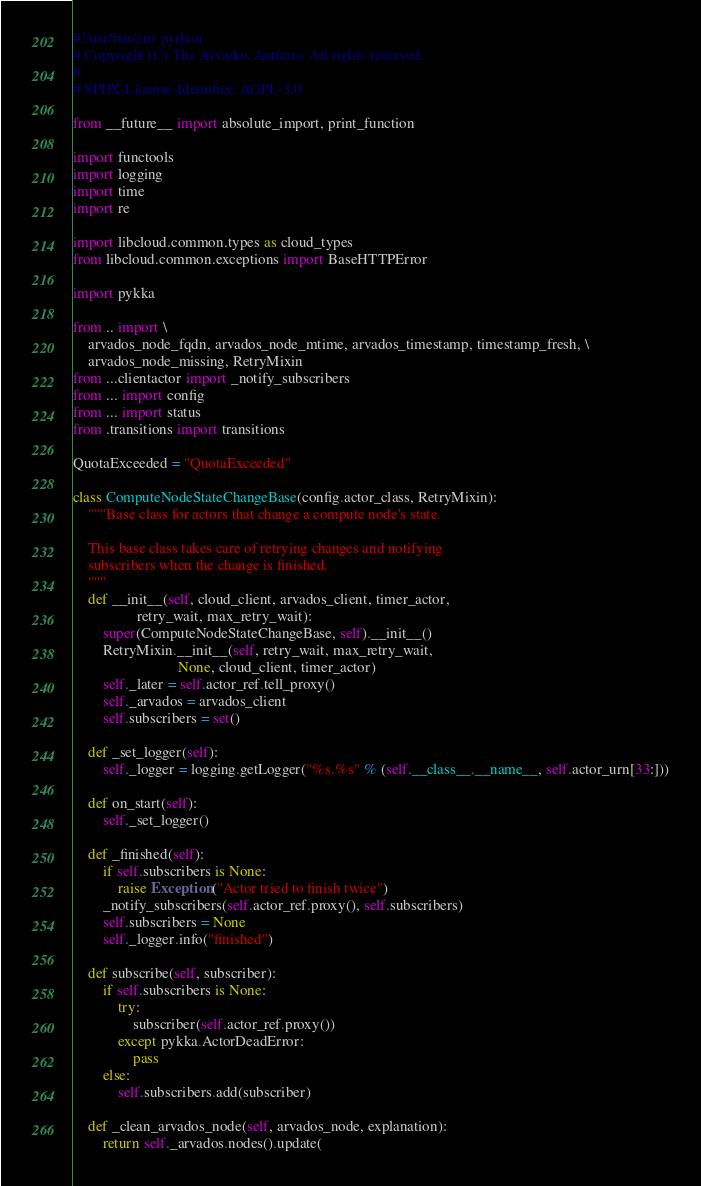<code> <loc_0><loc_0><loc_500><loc_500><_Python_>#!/usr/bin/env python
# Copyright (C) The Arvados Authors. All rights reserved.
#
# SPDX-License-Identifier: AGPL-3.0

from __future__ import absolute_import, print_function

import functools
import logging
import time
import re

import libcloud.common.types as cloud_types
from libcloud.common.exceptions import BaseHTTPError

import pykka

from .. import \
    arvados_node_fqdn, arvados_node_mtime, arvados_timestamp, timestamp_fresh, \
    arvados_node_missing, RetryMixin
from ...clientactor import _notify_subscribers
from ... import config
from ... import status
from .transitions import transitions

QuotaExceeded = "QuotaExceeded"

class ComputeNodeStateChangeBase(config.actor_class, RetryMixin):
    """Base class for actors that change a compute node's state.

    This base class takes care of retrying changes and notifying
    subscribers when the change is finished.
    """
    def __init__(self, cloud_client, arvados_client, timer_actor,
                 retry_wait, max_retry_wait):
        super(ComputeNodeStateChangeBase, self).__init__()
        RetryMixin.__init__(self, retry_wait, max_retry_wait,
                            None, cloud_client, timer_actor)
        self._later = self.actor_ref.tell_proxy()
        self._arvados = arvados_client
        self.subscribers = set()

    def _set_logger(self):
        self._logger = logging.getLogger("%s.%s" % (self.__class__.__name__, self.actor_urn[33:]))

    def on_start(self):
        self._set_logger()

    def _finished(self):
        if self.subscribers is None:
            raise Exception("Actor tried to finish twice")
        _notify_subscribers(self.actor_ref.proxy(), self.subscribers)
        self.subscribers = None
        self._logger.info("finished")

    def subscribe(self, subscriber):
        if self.subscribers is None:
            try:
                subscriber(self.actor_ref.proxy())
            except pykka.ActorDeadError:
                pass
        else:
            self.subscribers.add(subscriber)

    def _clean_arvados_node(self, arvados_node, explanation):
        return self._arvados.nodes().update(</code> 